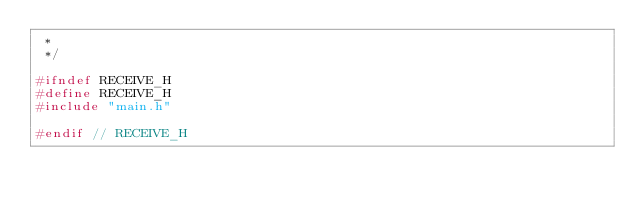Convert code to text. <code><loc_0><loc_0><loc_500><loc_500><_C_> *
 */

#ifndef RECEIVE_H
#define RECEIVE_H
#include "main.h"

#endif // RECEIVE_H
</code> 